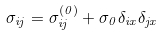<formula> <loc_0><loc_0><loc_500><loc_500>\sigma _ { i j } = \sigma _ { i j } ^ { ( 0 ) } + \sigma _ { 0 } \delta _ { i x } \delta _ { j x }</formula> 